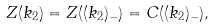Convert formula to latex. <formula><loc_0><loc_0><loc_500><loc_500>Z ( k _ { 2 } ) = Z ( ( k _ { 2 } ) _ { - } ) = C ( ( k _ { 2 } ) _ { - } ) ,</formula> 